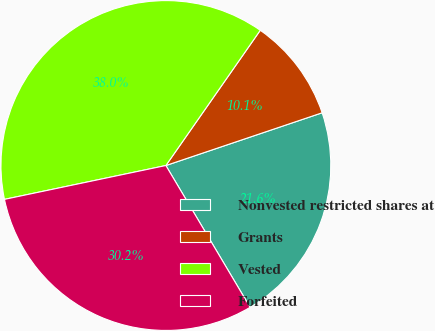Convert chart. <chart><loc_0><loc_0><loc_500><loc_500><pie_chart><fcel>Nonvested restricted shares at<fcel>Grants<fcel>Vested<fcel>Forfeited<nl><fcel>21.65%<fcel>10.12%<fcel>37.99%<fcel>30.24%<nl></chart> 